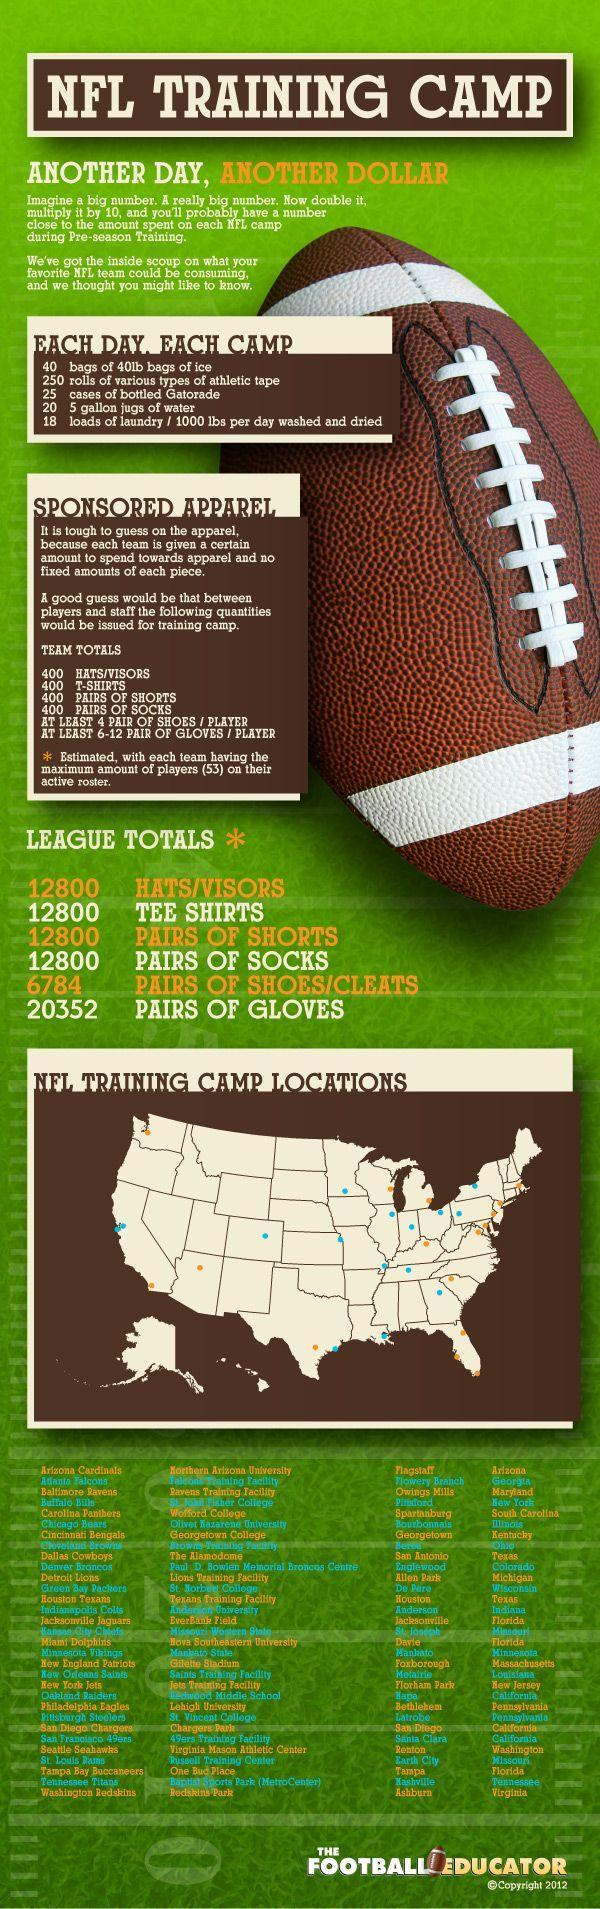Which stadiums in California are used as NFL Training Camp?
Answer the question with a short phrase. Hapa, San Diego, Santa Clara What is the quantity of sponsored hats, T-shirts, shorts and socks for league matches? 12800 